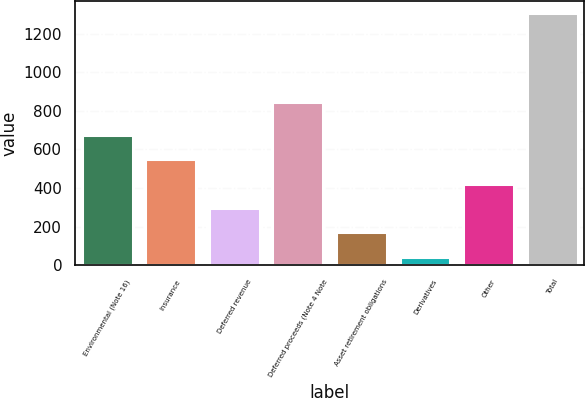Convert chart. <chart><loc_0><loc_0><loc_500><loc_500><bar_chart><fcel>Environmental (Note 16)<fcel>Insurance<fcel>Deferred revenue<fcel>Deferred proceeds (Note 4 Note<fcel>Asset retirement obligations<fcel>Derivatives<fcel>Other<fcel>Total<nl><fcel>675<fcel>548.8<fcel>296.4<fcel>846<fcel>170.2<fcel>44<fcel>422.6<fcel>1306<nl></chart> 